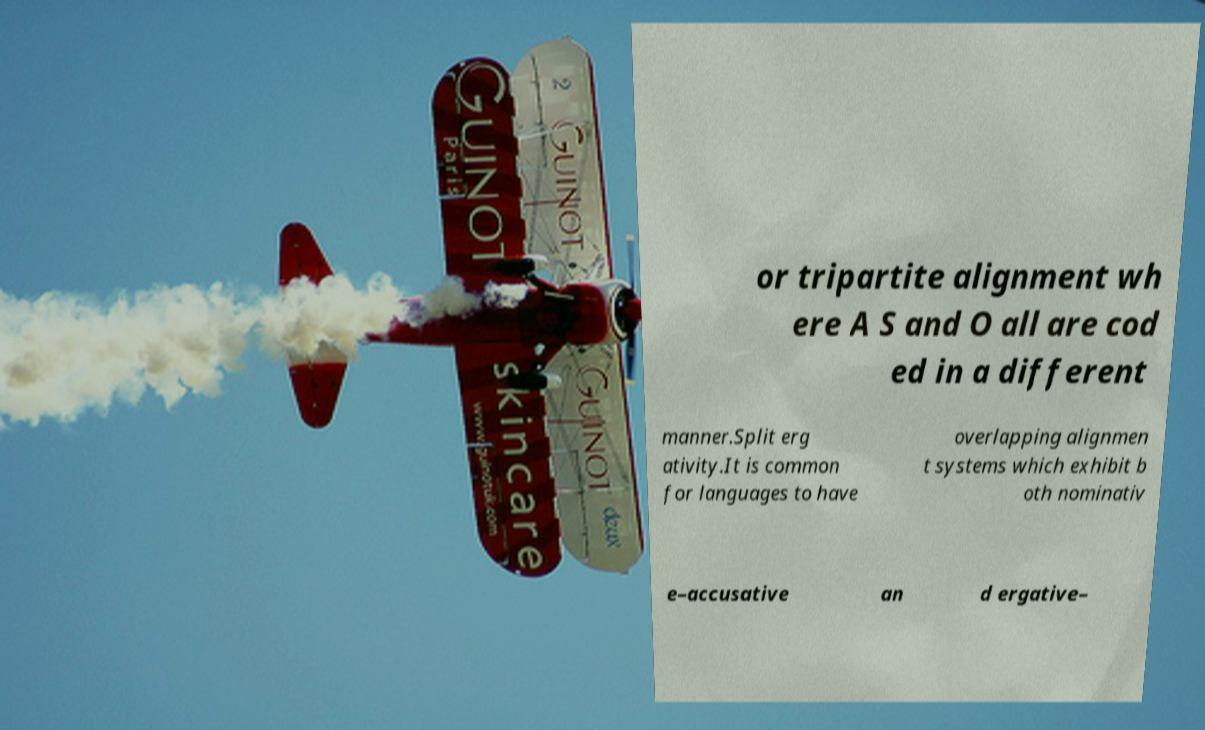There's text embedded in this image that I need extracted. Can you transcribe it verbatim? or tripartite alignment wh ere A S and O all are cod ed in a different manner.Split erg ativity.It is common for languages to have overlapping alignmen t systems which exhibit b oth nominativ e–accusative an d ergative– 